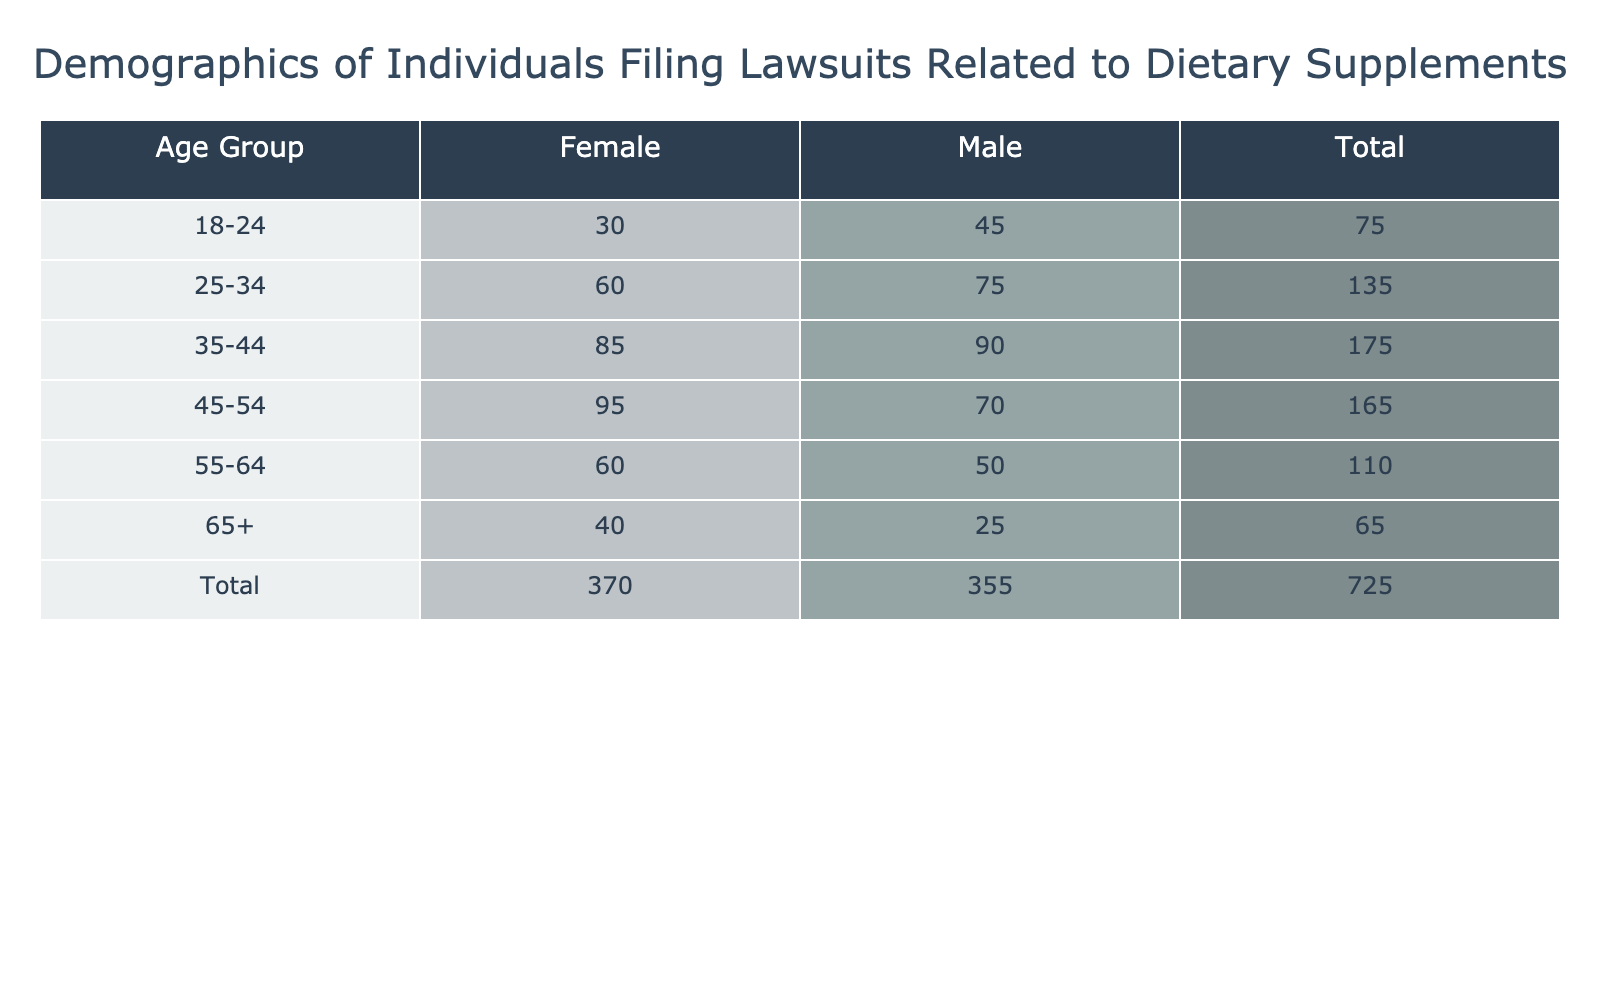What is the total number of lawsuits filed by females in the age group 45-54? In the age group 45-54, the number of lawsuits filed by females is reported as 95. There are no additional steps required as this value can be directly found in the table.
Answer: 95 What is the total number of lawsuits filed by males across all age groups? To find the total for males, we sum the lawsuits across all age groups: 45 + 75 + 90 + 70 + 50 + 25 = 355. Thus, the total number of lawsuits filed by males is 355.
Answer: 355 Is the number of lawsuits filed by females in the age group 25-34 greater than the number filed by males in the same age group? The number of lawsuits filed by females in the age group 25-34 is 60, while for males it is 75. Since 60 is less than 75, the statement is false.
Answer: No What is the difference in the number of lawsuits filed by females in the age group 18-24 compared to females in the age group 55-64? In the age group 18-24, the number of lawsuits filed by females is 30. In the age group 55-64, it is 60. Therefore, the difference is 60 - 30 = 30.
Answer: 30 What percentage of total lawsuits filed are attributed to males in the 35-44 age group? First, we need to calculate the total number of lawsuits filed: 45 + 30 + 75 + 60 + 90 + 85 + 70 + 95 + 50 + 60 + 25 + 40 =  735. The number of lawsuits filed by males in the 35-44 age group is 90. To find the percentage, we calculate (90/735) * 100 = approximately 12.24%.
Answer: 12.24% Are there more lawsuits filed by females aged 65 and older than males in that age group? The number of lawsuits filed by females aged 65 and older is 40, while for males it is 25. Since 40 is greater than 25, the answer is yes.
Answer: Yes What is the average number of lawsuits filed by females across all age groups? We sum the number of lawsuits filed by females: 30 + 60 + 85 + 95 + 60 + 40 = 370. There are 6 age groups for females. The average is 370 / 6 = approximately 61.67.
Answer: 61.67 How many more lawsuits were filed by males in the 25-34 age group compared to the 18-24 age group? In the 25-34 age group, males filed 75 lawsuits, while in the 18-24 age group, they filed 45. The difference is 75 - 45 = 30 lawsuits.
Answer: 30 What is the total number of lawsuits filed across all females and age groups? We need to sum up the respective female entries: 30 + 60 + 85 + 95 + 60 + 40 = 370.
Answer: 370 